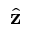Convert formula to latex. <formula><loc_0><loc_0><loc_500><loc_500>\hat { \mathbf z }</formula> 